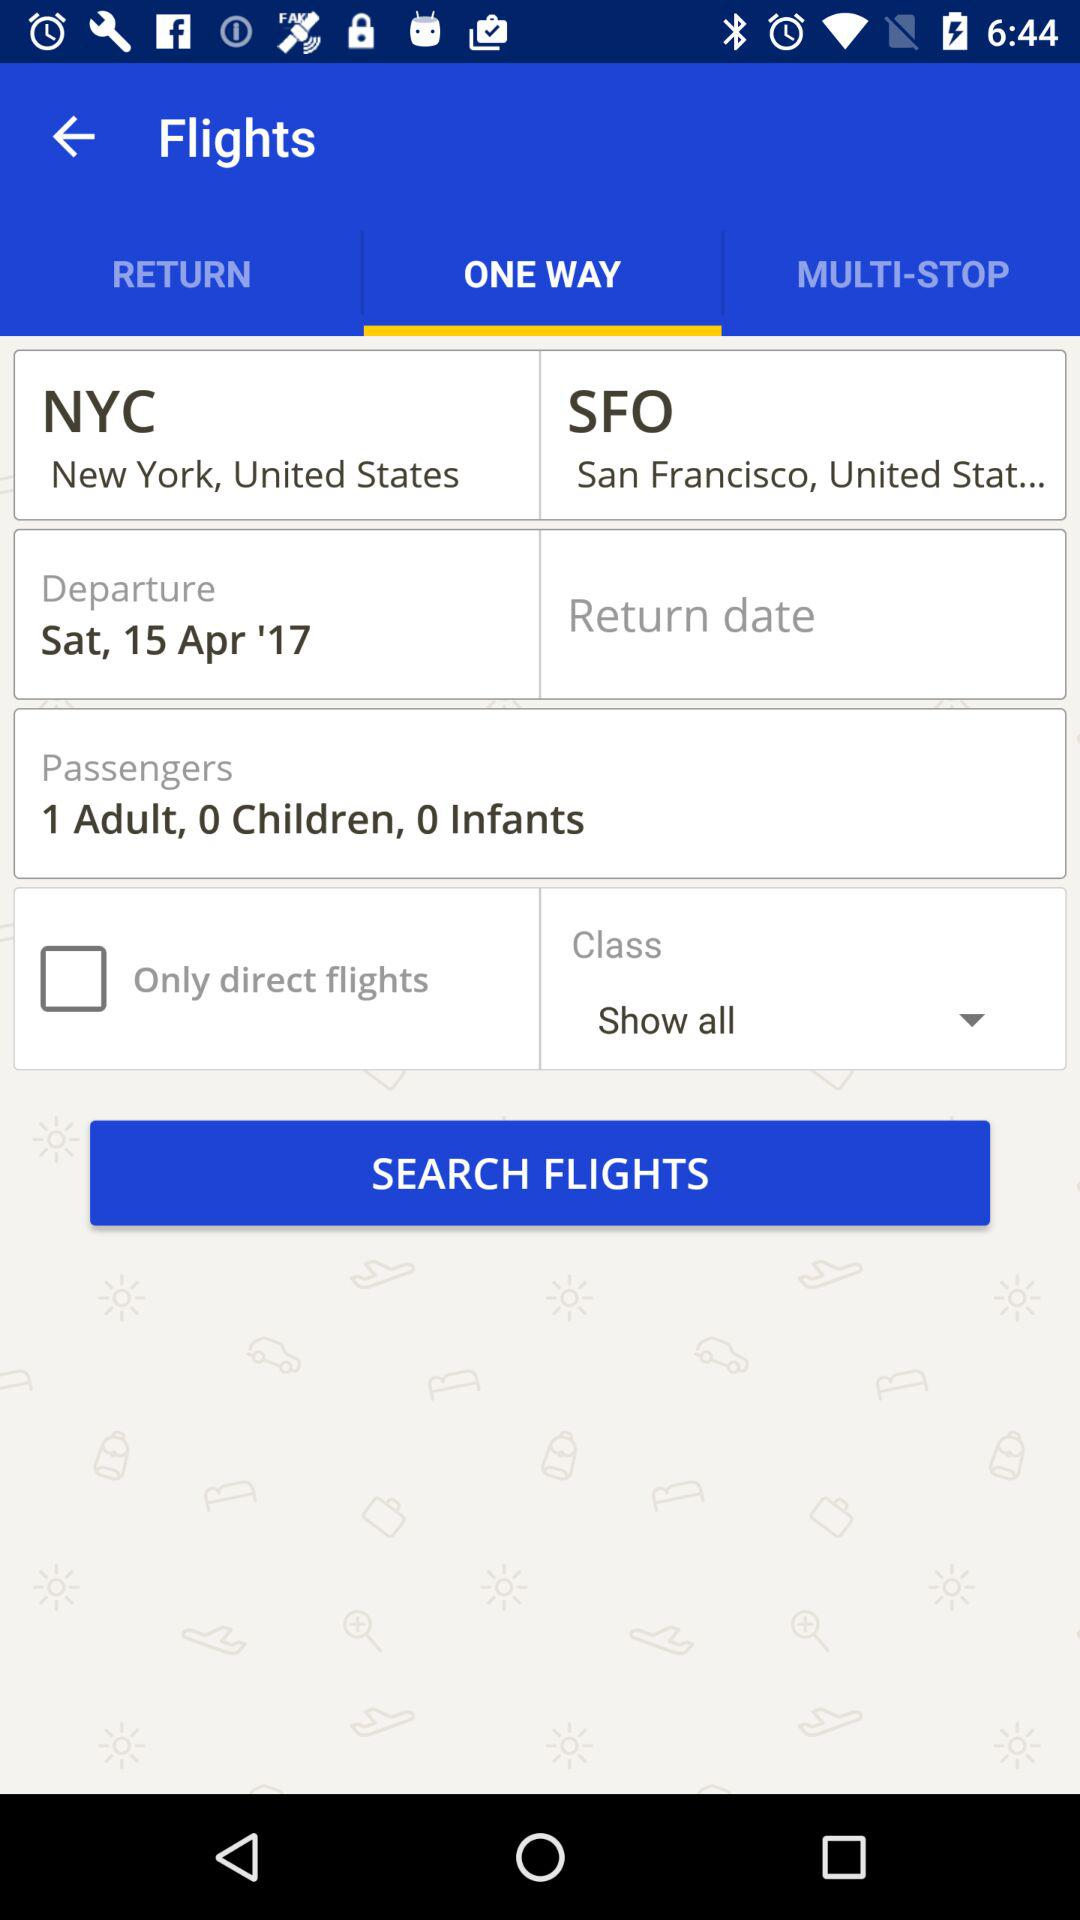What is the departure date? The departure date is Saturday, April 15, 2017. 